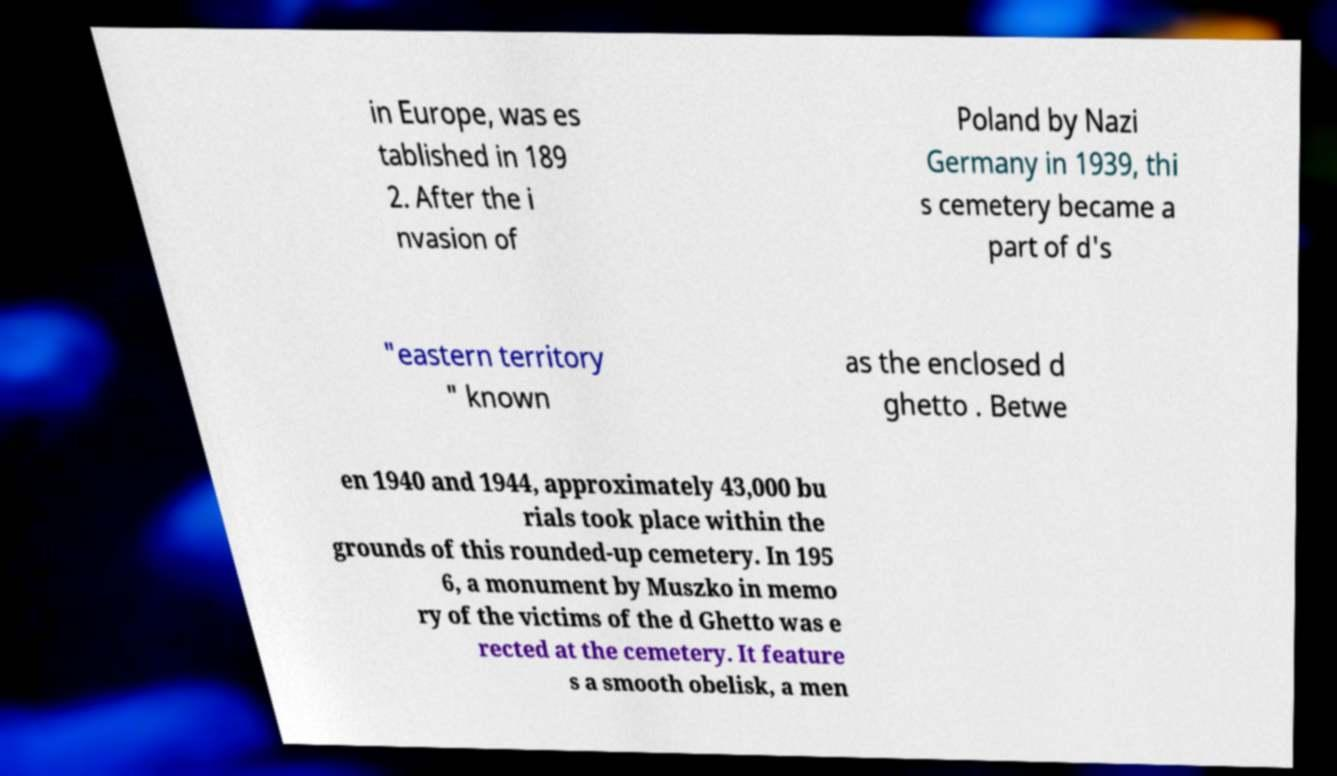What messages or text are displayed in this image? I need them in a readable, typed format. in Europe, was es tablished in 189 2. After the i nvasion of Poland by Nazi Germany in 1939, thi s cemetery became a part of d's "eastern territory " known as the enclosed d ghetto . Betwe en 1940 and 1944, approximately 43,000 bu rials took place within the grounds of this rounded-up cemetery. In 195 6, a monument by Muszko in memo ry of the victims of the d Ghetto was e rected at the cemetery. It feature s a smooth obelisk, a men 